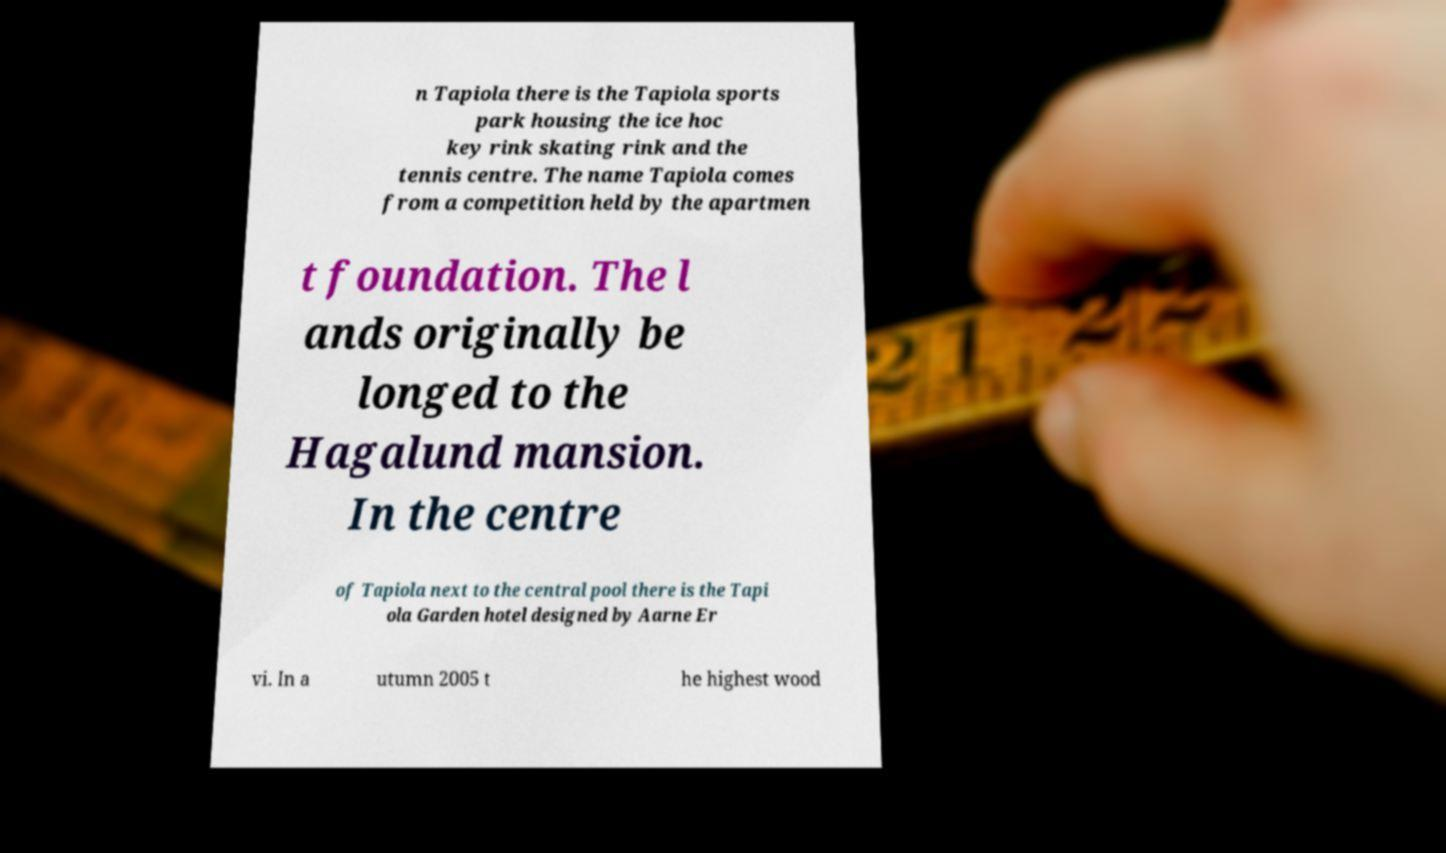There's text embedded in this image that I need extracted. Can you transcribe it verbatim? n Tapiola there is the Tapiola sports park housing the ice hoc key rink skating rink and the tennis centre. The name Tapiola comes from a competition held by the apartmen t foundation. The l ands originally be longed to the Hagalund mansion. In the centre of Tapiola next to the central pool there is the Tapi ola Garden hotel designed by Aarne Er vi. In a utumn 2005 t he highest wood 